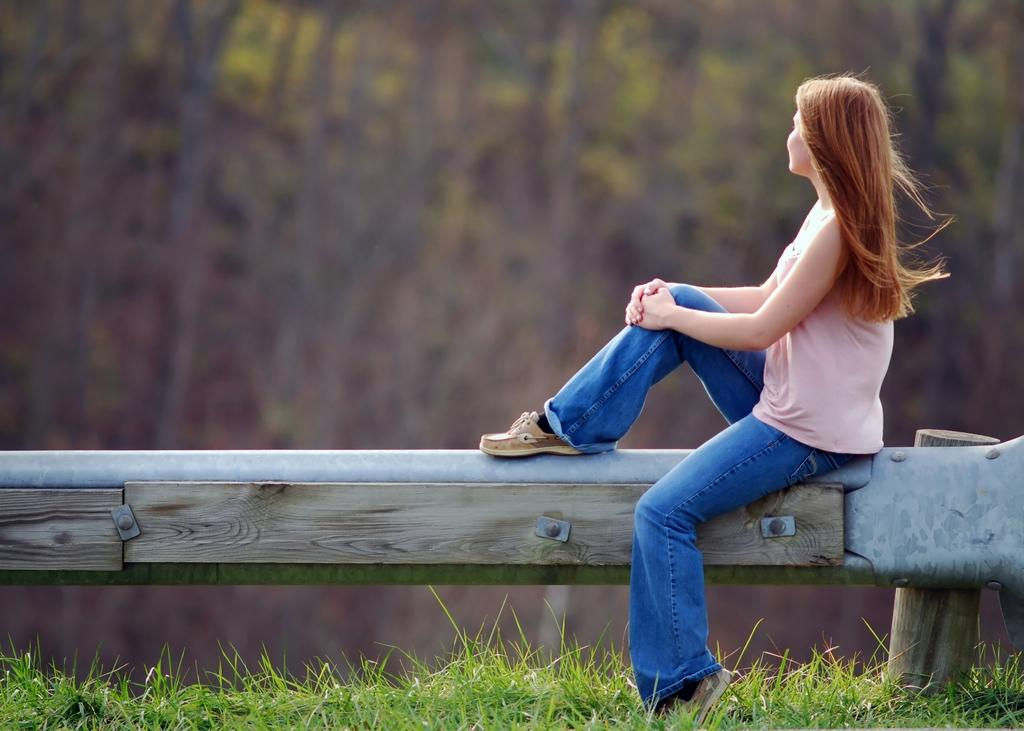What is the woman in the image doing? The woman is sitting in the image. Where is the woman sitting? The woman is sitting on a bench. What type of vegetation is visible at the bottom of the image? There is grass at the bottom of the image. What is the color of the grass? The grass is green in color. How would you describe the background of the image? The background of the image appears blurry. What type of school can be seen in the background of the image? There is no school visible in the background of the image. 